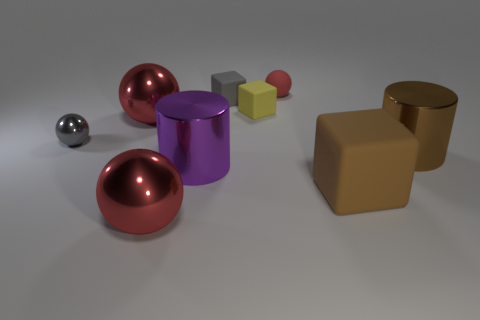There is a thing that is left of the tiny yellow cube and on the right side of the big purple metallic cylinder; what is its size?
Your answer should be very brief. Small. How many gray metallic spheres are there?
Provide a short and direct response. 1. What number of cylinders are either large objects or yellow objects?
Your answer should be compact. 2. How many yellow rubber cubes are in front of the big ball that is in front of the gray thing in front of the yellow rubber cube?
Your answer should be very brief. 0. The other sphere that is the same size as the gray shiny sphere is what color?
Offer a very short reply. Red. How many other objects are there of the same color as the small matte sphere?
Provide a short and direct response. 2. Is the number of gray objects that are on the right side of the tiny gray sphere greater than the number of small cyan cylinders?
Your answer should be very brief. Yes. Is the material of the big cube the same as the small yellow object?
Ensure brevity in your answer.  Yes. What number of objects are metal things that are in front of the large brown cylinder or brown objects?
Offer a very short reply. 4. What number of other objects are the same size as the brown cylinder?
Keep it short and to the point. 4. 